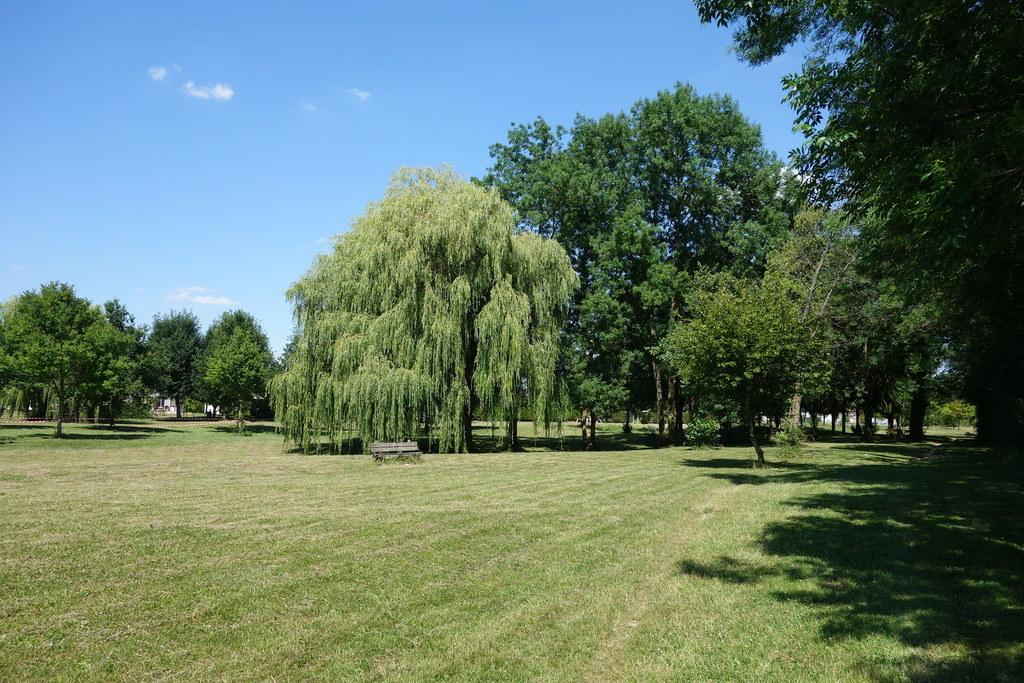What type of ground surface is visible in the image? There is grass on the ground in the image. What can be seen in the distance in the image? There are trees in the background of the image. What else is visible in the background of the image? The sky is visible in the background of the image. What type of sail can be seen on the grass in the image? There is no sail present in the image; it features grass on the ground, trees in the background, and the sky visible in the background. 